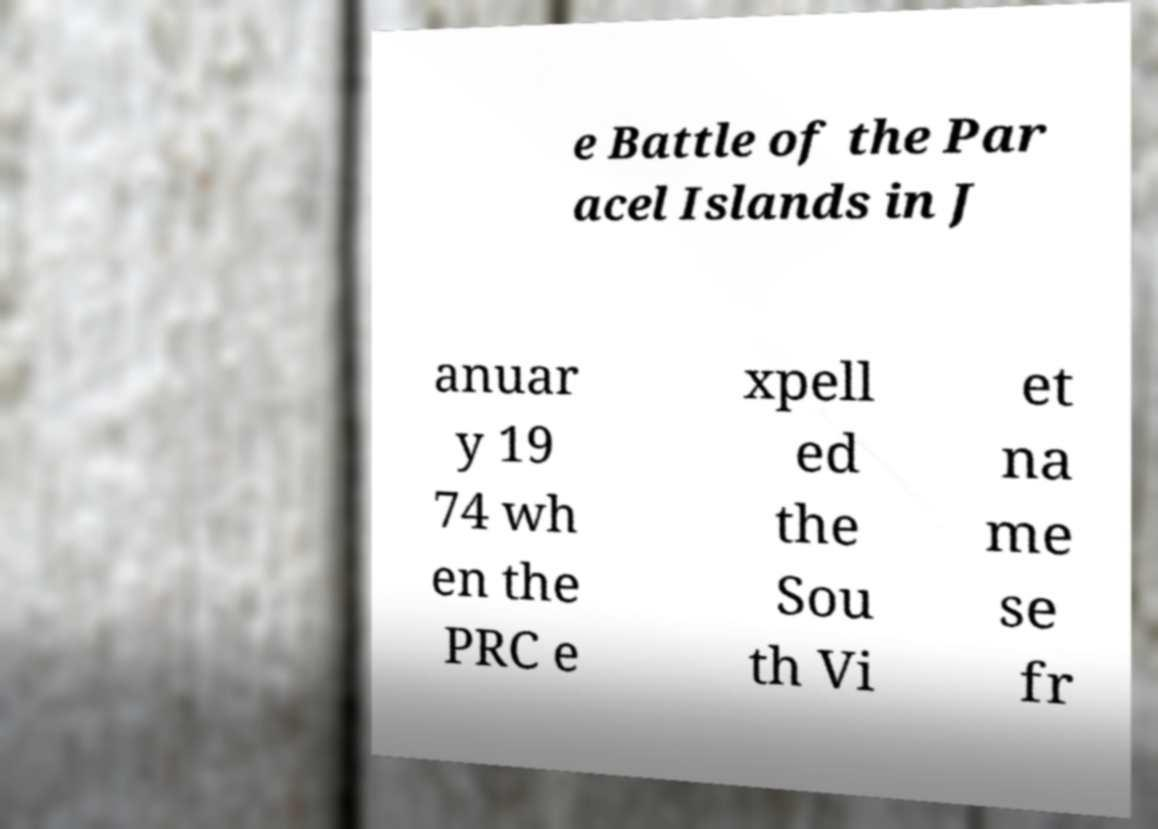There's text embedded in this image that I need extracted. Can you transcribe it verbatim? e Battle of the Par acel Islands in J anuar y 19 74 wh en the PRC e xpell ed the Sou th Vi et na me se fr 